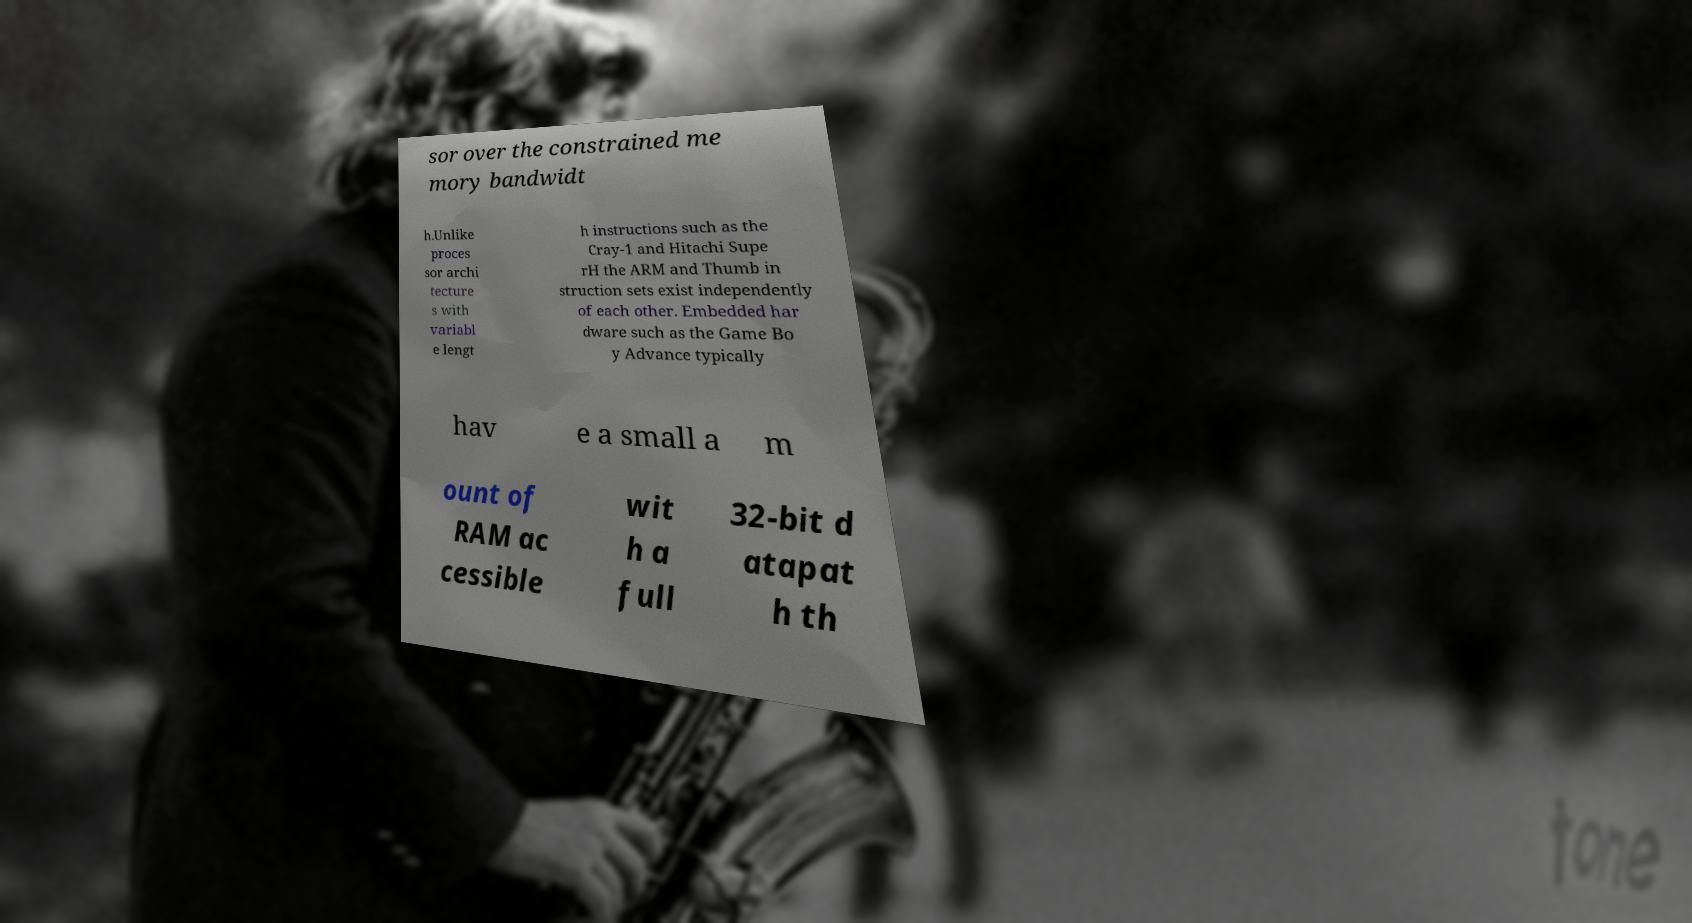I need the written content from this picture converted into text. Can you do that? sor over the constrained me mory bandwidt h.Unlike proces sor archi tecture s with variabl e lengt h instructions such as the Cray-1 and Hitachi Supe rH the ARM and Thumb in struction sets exist independently of each other. Embedded har dware such as the Game Bo y Advance typically hav e a small a m ount of RAM ac cessible wit h a full 32-bit d atapat h th 